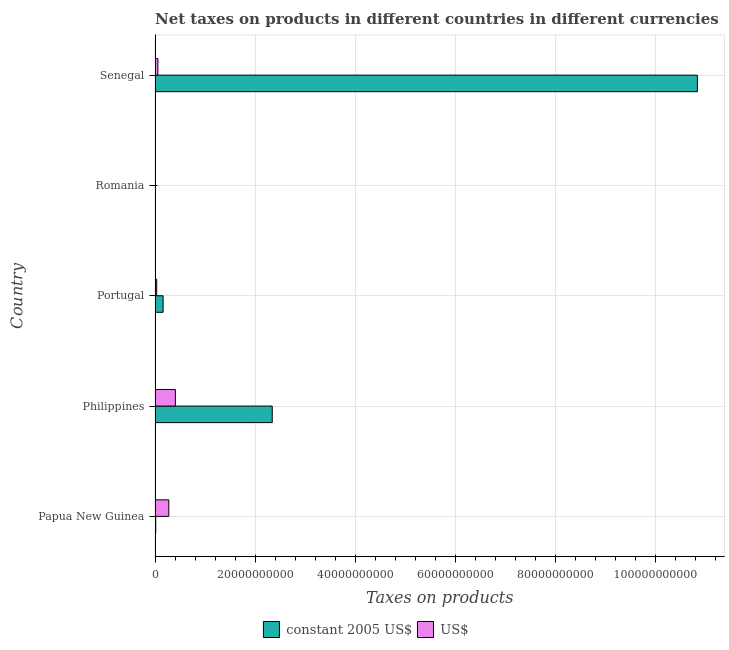How many different coloured bars are there?
Ensure brevity in your answer.  2. Are the number of bars per tick equal to the number of legend labels?
Provide a succinct answer. Yes. Are the number of bars on each tick of the Y-axis equal?
Offer a terse response. Yes. How many bars are there on the 5th tick from the top?
Ensure brevity in your answer.  2. How many bars are there on the 1st tick from the bottom?
Keep it short and to the point. 2. What is the label of the 2nd group of bars from the top?
Your response must be concise. Romania. What is the net taxes in us$ in Romania?
Make the answer very short. 8.15e+07. Across all countries, what is the maximum net taxes in constant 2005 us$?
Your response must be concise. 1.08e+11. Across all countries, what is the minimum net taxes in constant 2005 us$?
Offer a very short reply. 6.50e+06. In which country was the net taxes in constant 2005 us$ maximum?
Give a very brief answer. Senegal. In which country was the net taxes in constant 2005 us$ minimum?
Your answer should be very brief. Romania. What is the total net taxes in us$ in the graph?
Your answer should be very brief. 7.78e+09. What is the difference between the net taxes in constant 2005 us$ in Papua New Guinea and that in Romania?
Keep it short and to the point. 1.28e+08. What is the difference between the net taxes in constant 2005 us$ in Romania and the net taxes in us$ in Portugal?
Make the answer very short. -3.23e+08. What is the average net taxes in us$ per country?
Give a very brief answer. 1.56e+09. What is the difference between the net taxes in constant 2005 us$ and net taxes in us$ in Philippines?
Offer a very short reply. 1.94e+1. In how many countries, is the net taxes in constant 2005 us$ greater than 84000000000 units?
Your answer should be compact. 1. What is the ratio of the net taxes in us$ in Philippines to that in Senegal?
Your answer should be very brief. 7.21. What is the difference between the highest and the second highest net taxes in us$?
Give a very brief answer. 1.32e+09. What is the difference between the highest and the lowest net taxes in us$?
Offer a very short reply. 3.98e+09. What does the 2nd bar from the top in Papua New Guinea represents?
Ensure brevity in your answer.  Constant 2005 us$. What does the 1st bar from the bottom in Senegal represents?
Provide a succinct answer. Constant 2005 us$. How many bars are there?
Your response must be concise. 10. How many countries are there in the graph?
Make the answer very short. 5. What is the difference between two consecutive major ticks on the X-axis?
Your response must be concise. 2.00e+1. Are the values on the major ticks of X-axis written in scientific E-notation?
Provide a succinct answer. No. Does the graph contain any zero values?
Offer a very short reply. No. Does the graph contain grids?
Ensure brevity in your answer.  Yes. Where does the legend appear in the graph?
Ensure brevity in your answer.  Bottom center. What is the title of the graph?
Keep it short and to the point. Net taxes on products in different countries in different currencies. Does "Imports" appear as one of the legend labels in the graph?
Provide a short and direct response. No. What is the label or title of the X-axis?
Ensure brevity in your answer.  Taxes on products. What is the Taxes on products in constant 2005 US$ in Papua New Guinea?
Ensure brevity in your answer.  1.34e+08. What is the Taxes on products in US$ in Papua New Guinea?
Your answer should be compact. 2.74e+09. What is the Taxes on products of constant 2005 US$ in Philippines?
Provide a short and direct response. 2.34e+1. What is the Taxes on products of US$ in Philippines?
Keep it short and to the point. 4.06e+09. What is the Taxes on products of constant 2005 US$ in Portugal?
Offer a very short reply. 1.61e+09. What is the Taxes on products of US$ in Portugal?
Keep it short and to the point. 3.30e+08. What is the Taxes on products of constant 2005 US$ in Romania?
Your answer should be compact. 6.50e+06. What is the Taxes on products in US$ in Romania?
Offer a terse response. 8.15e+07. What is the Taxes on products of constant 2005 US$ in Senegal?
Keep it short and to the point. 1.08e+11. What is the Taxes on products of US$ in Senegal?
Offer a very short reply. 5.63e+08. Across all countries, what is the maximum Taxes on products of constant 2005 US$?
Provide a succinct answer. 1.08e+11. Across all countries, what is the maximum Taxes on products of US$?
Your response must be concise. 4.06e+09. Across all countries, what is the minimum Taxes on products in constant 2005 US$?
Keep it short and to the point. 6.50e+06. Across all countries, what is the minimum Taxes on products in US$?
Your answer should be compact. 8.15e+07. What is the total Taxes on products of constant 2005 US$ in the graph?
Your answer should be very brief. 1.34e+11. What is the total Taxes on products in US$ in the graph?
Give a very brief answer. 7.78e+09. What is the difference between the Taxes on products in constant 2005 US$ in Papua New Guinea and that in Philippines?
Offer a very short reply. -2.33e+1. What is the difference between the Taxes on products of US$ in Papua New Guinea and that in Philippines?
Give a very brief answer. -1.32e+09. What is the difference between the Taxes on products of constant 2005 US$ in Papua New Guinea and that in Portugal?
Provide a short and direct response. -1.48e+09. What is the difference between the Taxes on products in US$ in Papua New Guinea and that in Portugal?
Offer a very short reply. 2.41e+09. What is the difference between the Taxes on products of constant 2005 US$ in Papua New Guinea and that in Romania?
Ensure brevity in your answer.  1.28e+08. What is the difference between the Taxes on products of US$ in Papua New Guinea and that in Romania?
Keep it short and to the point. 2.66e+09. What is the difference between the Taxes on products in constant 2005 US$ in Papua New Guinea and that in Senegal?
Your answer should be very brief. -1.08e+11. What is the difference between the Taxes on products in US$ in Papua New Guinea and that in Senegal?
Offer a terse response. 2.18e+09. What is the difference between the Taxes on products in constant 2005 US$ in Philippines and that in Portugal?
Offer a very short reply. 2.18e+1. What is the difference between the Taxes on products of US$ in Philippines and that in Portugal?
Keep it short and to the point. 3.73e+09. What is the difference between the Taxes on products of constant 2005 US$ in Philippines and that in Romania?
Your answer should be very brief. 2.34e+1. What is the difference between the Taxes on products in US$ in Philippines and that in Romania?
Your answer should be very brief. 3.98e+09. What is the difference between the Taxes on products in constant 2005 US$ in Philippines and that in Senegal?
Give a very brief answer. -8.50e+1. What is the difference between the Taxes on products in US$ in Philippines and that in Senegal?
Provide a short and direct response. 3.50e+09. What is the difference between the Taxes on products of constant 2005 US$ in Portugal and that in Romania?
Ensure brevity in your answer.  1.60e+09. What is the difference between the Taxes on products of US$ in Portugal and that in Romania?
Your response must be concise. 2.48e+08. What is the difference between the Taxes on products in constant 2005 US$ in Portugal and that in Senegal?
Keep it short and to the point. -1.07e+11. What is the difference between the Taxes on products of US$ in Portugal and that in Senegal?
Provide a succinct answer. -2.33e+08. What is the difference between the Taxes on products in constant 2005 US$ in Romania and that in Senegal?
Give a very brief answer. -1.08e+11. What is the difference between the Taxes on products of US$ in Romania and that in Senegal?
Your answer should be compact. -4.82e+08. What is the difference between the Taxes on products in constant 2005 US$ in Papua New Guinea and the Taxes on products in US$ in Philippines?
Offer a terse response. -3.93e+09. What is the difference between the Taxes on products of constant 2005 US$ in Papua New Guinea and the Taxes on products of US$ in Portugal?
Give a very brief answer. -1.95e+08. What is the difference between the Taxes on products in constant 2005 US$ in Papua New Guinea and the Taxes on products in US$ in Romania?
Give a very brief answer. 5.29e+07. What is the difference between the Taxes on products in constant 2005 US$ in Papua New Guinea and the Taxes on products in US$ in Senegal?
Ensure brevity in your answer.  -4.29e+08. What is the difference between the Taxes on products in constant 2005 US$ in Philippines and the Taxes on products in US$ in Portugal?
Ensure brevity in your answer.  2.31e+1. What is the difference between the Taxes on products in constant 2005 US$ in Philippines and the Taxes on products in US$ in Romania?
Make the answer very short. 2.33e+1. What is the difference between the Taxes on products in constant 2005 US$ in Philippines and the Taxes on products in US$ in Senegal?
Provide a succinct answer. 2.29e+1. What is the difference between the Taxes on products of constant 2005 US$ in Portugal and the Taxes on products of US$ in Romania?
Your answer should be very brief. 1.53e+09. What is the difference between the Taxes on products in constant 2005 US$ in Portugal and the Taxes on products in US$ in Senegal?
Ensure brevity in your answer.  1.05e+09. What is the difference between the Taxes on products of constant 2005 US$ in Romania and the Taxes on products of US$ in Senegal?
Make the answer very short. -5.57e+08. What is the average Taxes on products of constant 2005 US$ per country?
Your answer should be very brief. 2.67e+1. What is the average Taxes on products in US$ per country?
Make the answer very short. 1.56e+09. What is the difference between the Taxes on products in constant 2005 US$ and Taxes on products in US$ in Papua New Guinea?
Make the answer very short. -2.61e+09. What is the difference between the Taxes on products in constant 2005 US$ and Taxes on products in US$ in Philippines?
Offer a terse response. 1.94e+1. What is the difference between the Taxes on products of constant 2005 US$ and Taxes on products of US$ in Portugal?
Provide a succinct answer. 1.28e+09. What is the difference between the Taxes on products in constant 2005 US$ and Taxes on products in US$ in Romania?
Keep it short and to the point. -7.50e+07. What is the difference between the Taxes on products of constant 2005 US$ and Taxes on products of US$ in Senegal?
Keep it short and to the point. 1.08e+11. What is the ratio of the Taxes on products of constant 2005 US$ in Papua New Guinea to that in Philippines?
Make the answer very short. 0.01. What is the ratio of the Taxes on products in US$ in Papua New Guinea to that in Philippines?
Offer a very short reply. 0.68. What is the ratio of the Taxes on products in constant 2005 US$ in Papua New Guinea to that in Portugal?
Make the answer very short. 0.08. What is the ratio of the Taxes on products of US$ in Papua New Guinea to that in Portugal?
Offer a terse response. 8.31. What is the ratio of the Taxes on products in constant 2005 US$ in Papua New Guinea to that in Romania?
Provide a short and direct response. 20.68. What is the ratio of the Taxes on products of US$ in Papua New Guinea to that in Romania?
Offer a terse response. 33.63. What is the ratio of the Taxes on products of constant 2005 US$ in Papua New Guinea to that in Senegal?
Your answer should be very brief. 0. What is the ratio of the Taxes on products in US$ in Papua New Guinea to that in Senegal?
Provide a succinct answer. 4.87. What is the ratio of the Taxes on products of constant 2005 US$ in Philippines to that in Portugal?
Provide a succinct answer. 14.55. What is the ratio of the Taxes on products of US$ in Philippines to that in Portugal?
Ensure brevity in your answer.  12.31. What is the ratio of the Taxes on products in constant 2005 US$ in Philippines to that in Romania?
Ensure brevity in your answer.  3602.31. What is the ratio of the Taxes on products in US$ in Philippines to that in Romania?
Your answer should be compact. 49.8. What is the ratio of the Taxes on products of constant 2005 US$ in Philippines to that in Senegal?
Your answer should be very brief. 0.22. What is the ratio of the Taxes on products in US$ in Philippines to that in Senegal?
Make the answer very short. 7.21. What is the ratio of the Taxes on products in constant 2005 US$ in Portugal to that in Romania?
Provide a succinct answer. 247.63. What is the ratio of the Taxes on products of US$ in Portugal to that in Romania?
Ensure brevity in your answer.  4.04. What is the ratio of the Taxes on products in constant 2005 US$ in Portugal to that in Senegal?
Keep it short and to the point. 0.01. What is the ratio of the Taxes on products of US$ in Portugal to that in Senegal?
Provide a succinct answer. 0.59. What is the ratio of the Taxes on products in US$ in Romania to that in Senegal?
Give a very brief answer. 0.14. What is the difference between the highest and the second highest Taxes on products of constant 2005 US$?
Keep it short and to the point. 8.50e+1. What is the difference between the highest and the second highest Taxes on products of US$?
Provide a succinct answer. 1.32e+09. What is the difference between the highest and the lowest Taxes on products of constant 2005 US$?
Your answer should be very brief. 1.08e+11. What is the difference between the highest and the lowest Taxes on products of US$?
Make the answer very short. 3.98e+09. 